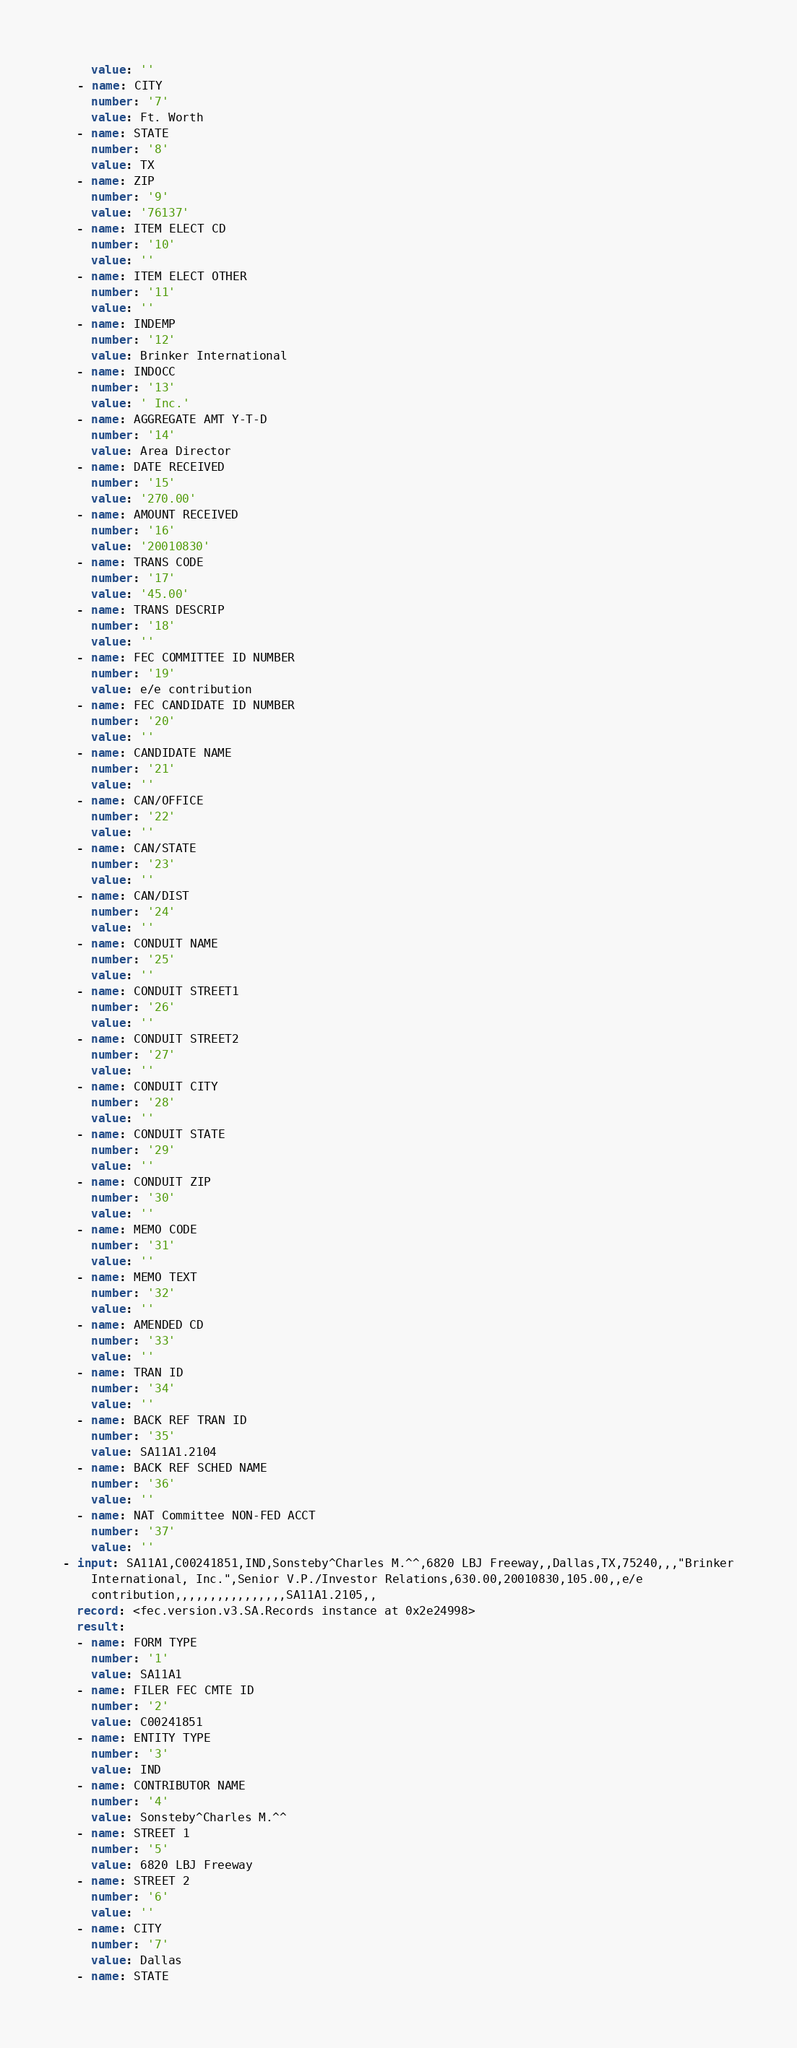Convert code to text. <code><loc_0><loc_0><loc_500><loc_500><_YAML_>    value: ''
  - name: CITY
    number: '7'
    value: Ft. Worth
  - name: STATE
    number: '8'
    value: TX
  - name: ZIP
    number: '9'
    value: '76137'
  - name: ITEM ELECT CD
    number: '10'
    value: ''
  - name: ITEM ELECT OTHER
    number: '11'
    value: ''
  - name: INDEMP
    number: '12'
    value: Brinker International
  - name: INDOCC
    number: '13'
    value: ' Inc.'
  - name: AGGREGATE AMT Y-T-D
    number: '14'
    value: Area Director
  - name: DATE RECEIVED
    number: '15'
    value: '270.00'
  - name: AMOUNT RECEIVED
    number: '16'
    value: '20010830'
  - name: TRANS CODE
    number: '17'
    value: '45.00'
  - name: TRANS DESCRIP
    number: '18'
    value: ''
  - name: FEC COMMITTEE ID NUMBER
    number: '19'
    value: e/e contribution
  - name: FEC CANDIDATE ID NUMBER
    number: '20'
    value: ''
  - name: CANDIDATE NAME
    number: '21'
    value: ''
  - name: CAN/OFFICE
    number: '22'
    value: ''
  - name: CAN/STATE
    number: '23'
    value: ''
  - name: CAN/DIST
    number: '24'
    value: ''
  - name: CONDUIT NAME
    number: '25'
    value: ''
  - name: CONDUIT STREET1
    number: '26'
    value: ''
  - name: CONDUIT STREET2
    number: '27'
    value: ''
  - name: CONDUIT CITY
    number: '28'
    value: ''
  - name: CONDUIT STATE
    number: '29'
    value: ''
  - name: CONDUIT ZIP
    number: '30'
    value: ''
  - name: MEMO CODE
    number: '31'
    value: ''
  - name: MEMO TEXT
    number: '32'
    value: ''
  - name: AMENDED CD
    number: '33'
    value: ''
  - name: TRAN ID
    number: '34'
    value: ''
  - name: BACK REF TRAN ID
    number: '35'
    value: SA11A1.2104
  - name: BACK REF SCHED NAME
    number: '36'
    value: ''
  - name: NAT Committee NON-FED ACCT
    number: '37'
    value: ''
- input: SA11A1,C00241851,IND,Sonsteby^Charles M.^^,6820 LBJ Freeway,,Dallas,TX,75240,,,"Brinker
    International, Inc.",Senior V.P./Investor Relations,630.00,20010830,105.00,,e/e
    contribution,,,,,,,,,,,,,,,,SA11A1.2105,,
  record: <fec.version.v3.SA.Records instance at 0x2e24998>
  result:
  - name: FORM TYPE
    number: '1'
    value: SA11A1
  - name: FILER FEC CMTE ID
    number: '2'
    value: C00241851
  - name: ENTITY TYPE
    number: '3'
    value: IND
  - name: CONTRIBUTOR NAME
    number: '4'
    value: Sonsteby^Charles M.^^
  - name: STREET 1
    number: '5'
    value: 6820 LBJ Freeway
  - name: STREET 2
    number: '6'
    value: ''
  - name: CITY
    number: '7'
    value: Dallas
  - name: STATE</code> 